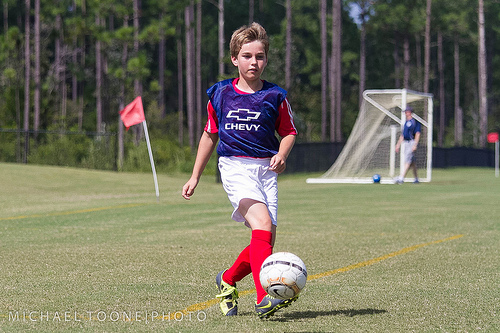<image>
Can you confirm if the football is on the ground? No. The football is not positioned on the ground. They may be near each other, but the football is not supported by or resting on top of the ground. Where is the ball in relation to the ground? Is it on the ground? No. The ball is not positioned on the ground. They may be near each other, but the ball is not supported by or resting on top of the ground. Is the boy above the ball? No. The boy is not positioned above the ball. The vertical arrangement shows a different relationship. 